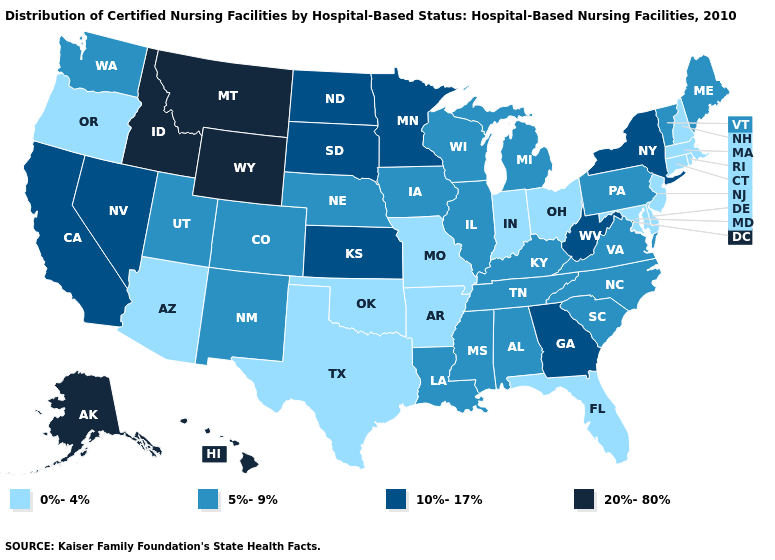Name the states that have a value in the range 10%-17%?
Short answer required. California, Georgia, Kansas, Minnesota, Nevada, New York, North Dakota, South Dakota, West Virginia. How many symbols are there in the legend?
Answer briefly. 4. What is the value of Minnesota?
Short answer required. 10%-17%. Does Connecticut have the same value as Oklahoma?
Concise answer only. Yes. Which states hav the highest value in the South?
Give a very brief answer. Georgia, West Virginia. Which states have the lowest value in the USA?
Answer briefly. Arizona, Arkansas, Connecticut, Delaware, Florida, Indiana, Maryland, Massachusetts, Missouri, New Hampshire, New Jersey, Ohio, Oklahoma, Oregon, Rhode Island, Texas. What is the value of North Dakota?
Keep it brief. 10%-17%. What is the value of Kentucky?
Be succinct. 5%-9%. Does Montana have the highest value in the West?
Be succinct. Yes. Which states have the lowest value in the South?
Be succinct. Arkansas, Delaware, Florida, Maryland, Oklahoma, Texas. Among the states that border Colorado , which have the highest value?
Short answer required. Wyoming. What is the highest value in the USA?
Give a very brief answer. 20%-80%. Does Nebraska have the highest value in the MidWest?
Give a very brief answer. No. 